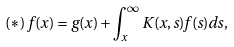Convert formula to latex. <formula><loc_0><loc_0><loc_500><loc_500>( \ast ) \, f ( x ) = g ( x ) + \int _ { x } ^ { \infty } K ( x , s ) f ( s ) d s ,</formula> 